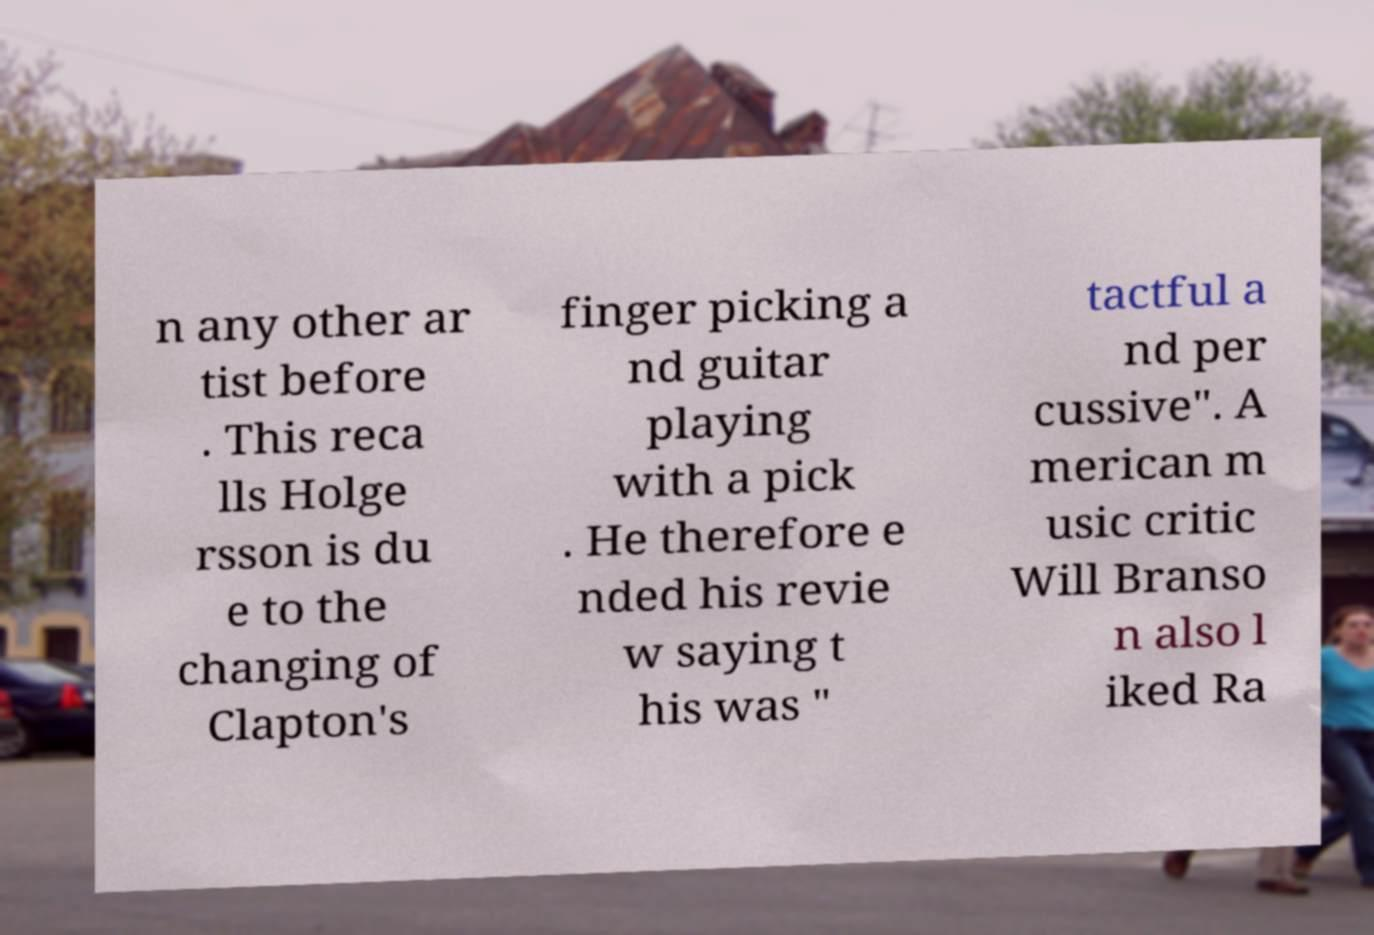Could you extract and type out the text from this image? n any other ar tist before . This reca lls Holge rsson is du e to the changing of Clapton's finger picking a nd guitar playing with a pick . He therefore e nded his revie w saying t his was " tactful a nd per cussive". A merican m usic critic Will Branso n also l iked Ra 